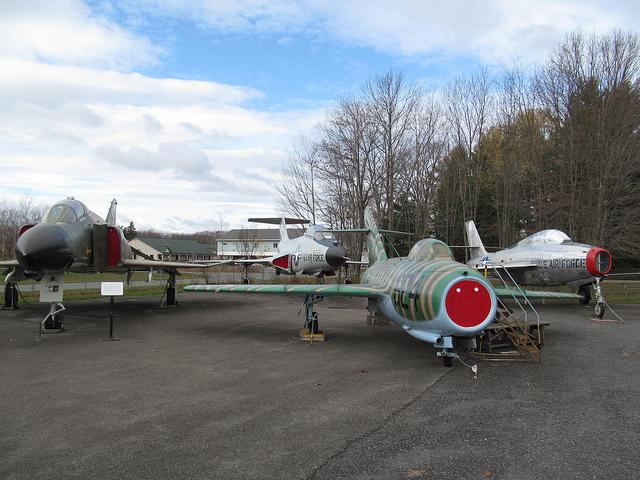The planes were likely used for what transportation purpose?

Choices:
A) cargo
B) waterways
C) military
D) passenger military 